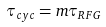Convert formula to latex. <formula><loc_0><loc_0><loc_500><loc_500>\tau _ { c y c } = m \tau _ { R F G }</formula> 